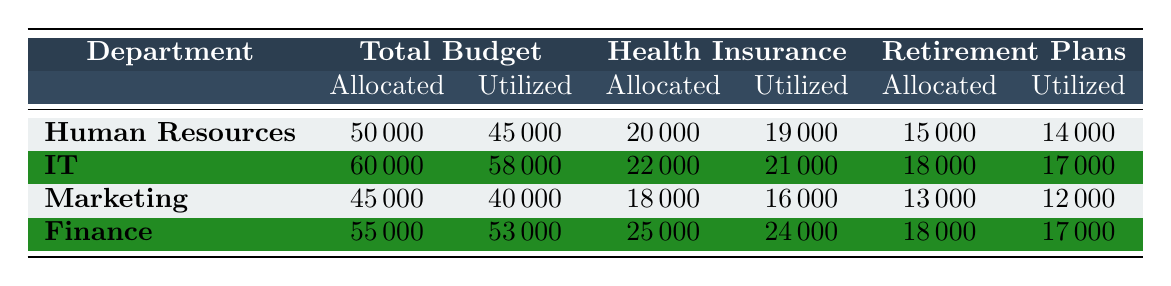What is the total budget allocated to the Human Resources department? According to the table, the total budget allocated to the Human Resources department is listed in the "Total Budget" section under "Budget Allocated," which shows the value of 50000.
Answer: 50000 How much budget was utilized by the IT department? The budget utilized by the IT department can be found in the "Total Budget" section under "Budget Utilized," which is specified as 58000.
Answer: 58000 What is the difference between the budget allocated and utilized for the Marketing department? For the Marketing department, the budget allocated is 45000 and the budget utilized is 40000. The difference is calculated as 45000 - 40000 = 5000.
Answer: 5000 Is the allocated budget for Health Insurance in the Finance department greater than that of the IT department? The allocated budget for Health Insurance in the Finance department is 25000, while for the IT department, it is 22000. Since 25000 is greater than 22000, the answer is yes.
Answer: Yes What is the average amount of budget utilized across all departments? The budget utilized for all departments can be added as follows: 45000 (HR) + 58000 (IT) + 40000 (Marketing) + 53000 (Finance) = 196000. There are 4 departments, so the average is calculated as 196000 / 4 = 49000.
Answer: 49000 Which department had the least amount of budget utilized? By comparing the budget utilized for all departments: 45000 (HR), 58000 (IT), 40000 (Marketing), and 53000 (Finance), it is clear that the Marketing department had the least at 40000.
Answer: Marketing What percentage of the budget was utilized for Training Programs in the Human Resources department? The budget allocated for Training Programs in the Human Resources department is 15000, and the budget utilized is 12000. The percentage utilized is calculated as (12000 / 15000) * 100 = 80%.
Answer: 80% Did any department fully utilize its allocated budget for Training Programs? The allocated budget for Training Programs for the IT department is 20000, and it was fully utilized as indicated by the same amount utilized (20000), leading to a conclusion that the report shows full utilization of the allocated budget.
Answer: Yes How much more was allocated to Health Insurance in the Finance department than in the Marketing department? The allocation for Health Insurance in Finance is 25000, and in Marketing, it is 18000. The calculation for the difference is 25000 - 18000 = 7000.
Answer: 7000 